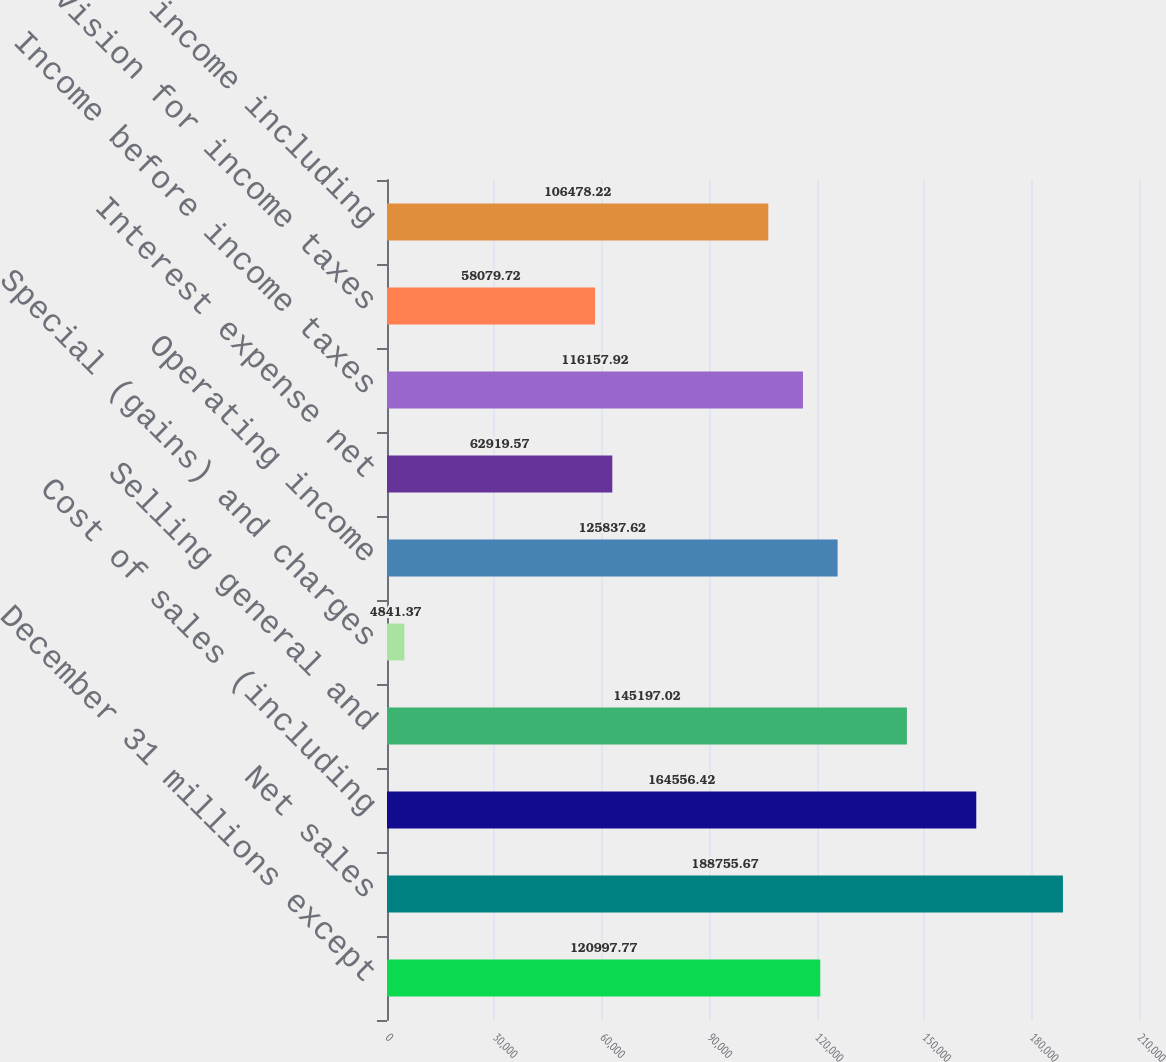Convert chart to OTSL. <chart><loc_0><loc_0><loc_500><loc_500><bar_chart><fcel>December 31 millions except<fcel>Net sales<fcel>Cost of sales (including<fcel>Selling general and<fcel>Special (gains) and charges<fcel>Operating income<fcel>Interest expense net<fcel>Income before income taxes<fcel>Provision for income taxes<fcel>Net income including<nl><fcel>120998<fcel>188756<fcel>164556<fcel>145197<fcel>4841.37<fcel>125838<fcel>62919.6<fcel>116158<fcel>58079.7<fcel>106478<nl></chart> 